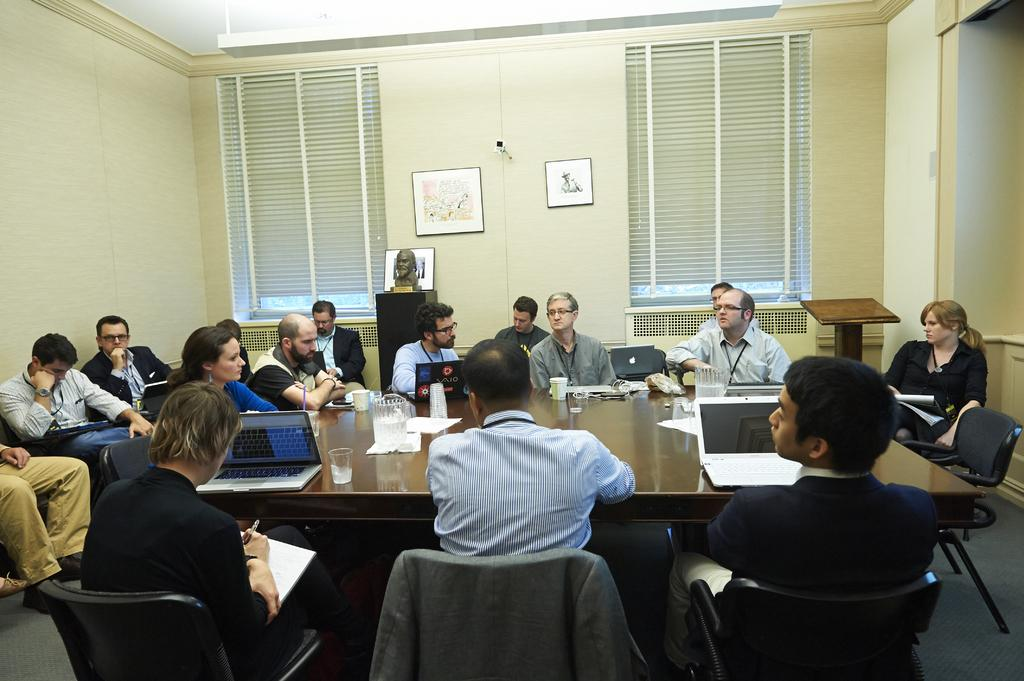Who is present in the image? There are people in the image. Where are the people located? The people are sitting in a conference room. What furniture is in the room? There is a table in the room. What electronic devices are on the table? There are laptops on the table. What else can be seen on the table? There are glasses on the table. How many lizards are crawling on the laptops in the image? There are no lizards present in the image; the laptops are not being crawled on by any lizards. 